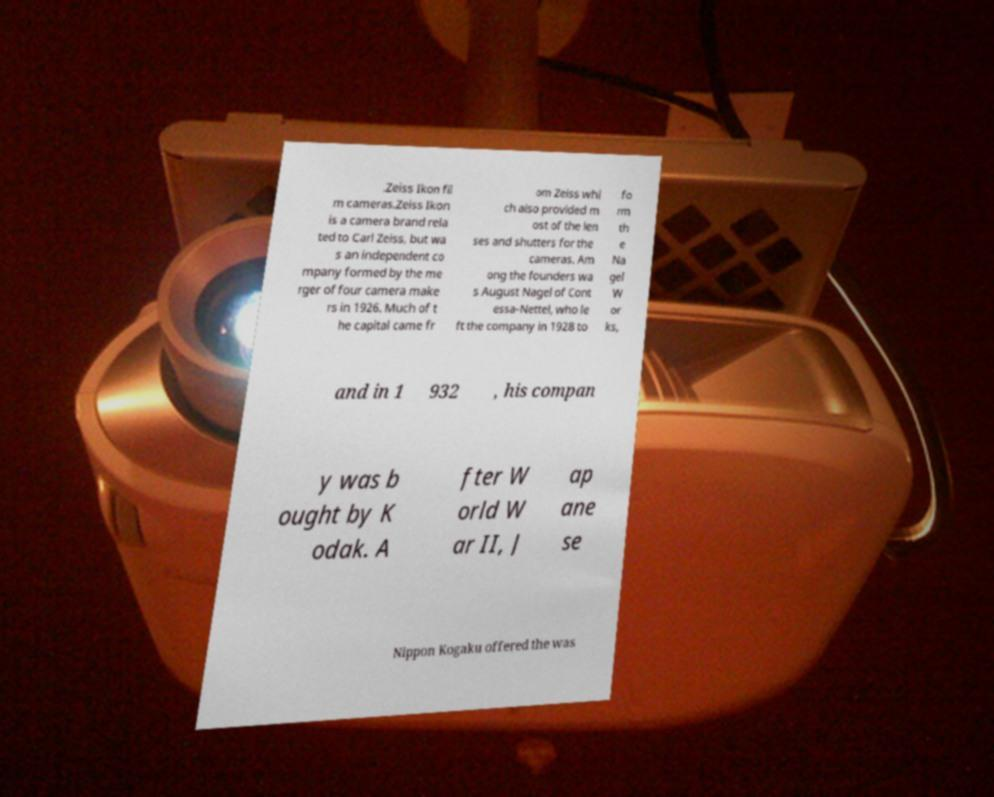What messages or text are displayed in this image? I need them in a readable, typed format. .Zeiss Ikon fil m cameras.Zeiss Ikon is a camera brand rela ted to Carl Zeiss, but wa s an independent co mpany formed by the me rger of four camera make rs in 1926. Much of t he capital came fr om Zeiss whi ch also provided m ost of the len ses and shutters for the cameras. Am ong the founders wa s August Nagel of Cont essa-Nettel, who le ft the company in 1928 to fo rm th e Na gel W or ks, and in 1 932 , his compan y was b ought by K odak. A fter W orld W ar II, J ap ane se Nippon Kogaku offered the was 